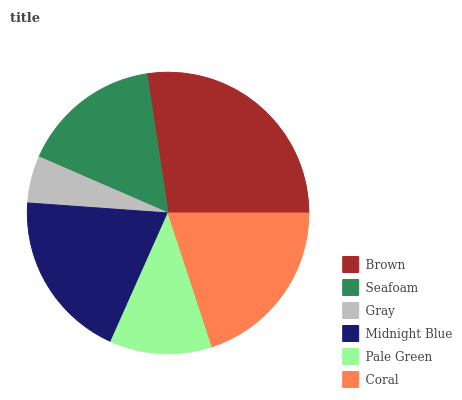Is Gray the minimum?
Answer yes or no. Yes. Is Brown the maximum?
Answer yes or no. Yes. Is Seafoam the minimum?
Answer yes or no. No. Is Seafoam the maximum?
Answer yes or no. No. Is Brown greater than Seafoam?
Answer yes or no. Yes. Is Seafoam less than Brown?
Answer yes or no. Yes. Is Seafoam greater than Brown?
Answer yes or no. No. Is Brown less than Seafoam?
Answer yes or no. No. Is Midnight Blue the high median?
Answer yes or no. Yes. Is Seafoam the low median?
Answer yes or no. Yes. Is Gray the high median?
Answer yes or no. No. Is Midnight Blue the low median?
Answer yes or no. No. 